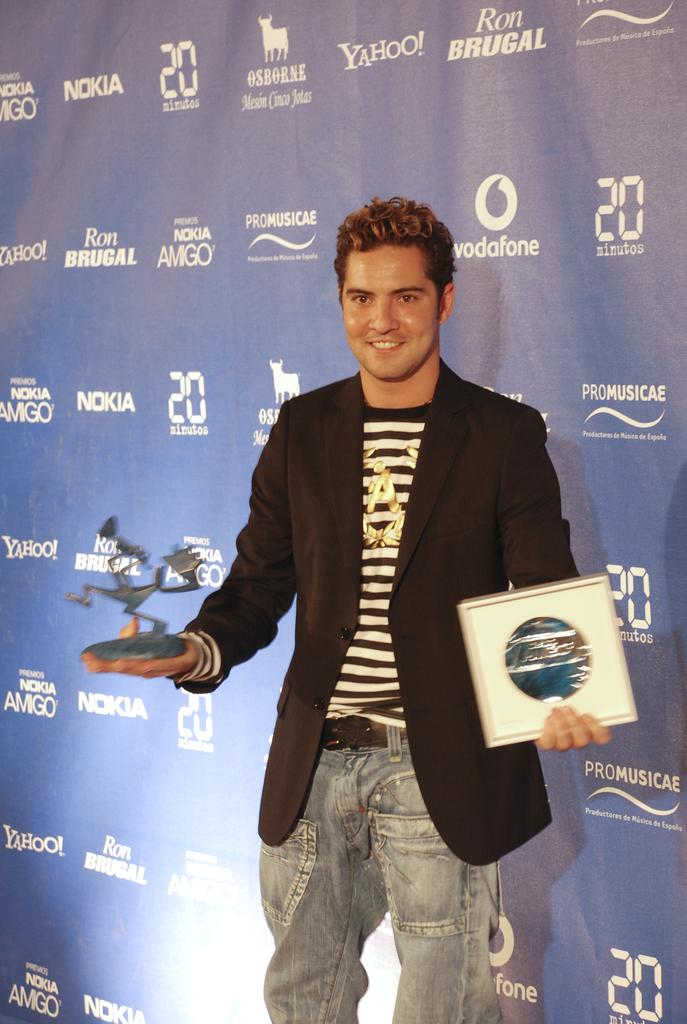What is the man in the image doing? The man is standing in the image and holding an object in one hand and a card in the other hand. Can you describe the object the man is holding? The fact does not specify the object the man is holding, so we cannot describe it. What can be seen in the background of the image? There is a hoarding in the background of the image. How many chairs are visible in the image? There are no chairs visible in the image. Is there a camp set up in the background of the image? There is no camp present in the image; it only features a man and a hoarding in the background. 